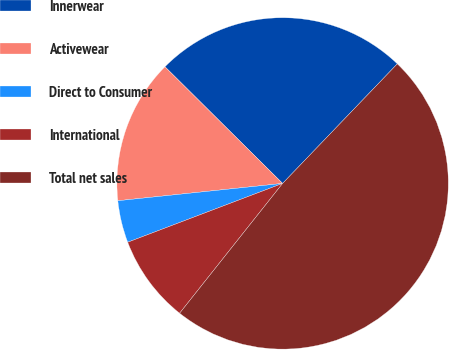<chart> <loc_0><loc_0><loc_500><loc_500><pie_chart><fcel>Innerwear<fcel>Activewear<fcel>Direct to Consumer<fcel>International<fcel>Total net sales<nl><fcel>24.74%<fcel>14.1%<fcel>4.11%<fcel>8.55%<fcel>48.51%<nl></chart> 